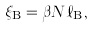<formula> <loc_0><loc_0><loc_500><loc_500>\xi _ { \text {B} } = \beta N \ell _ { \text {B} } ,</formula> 